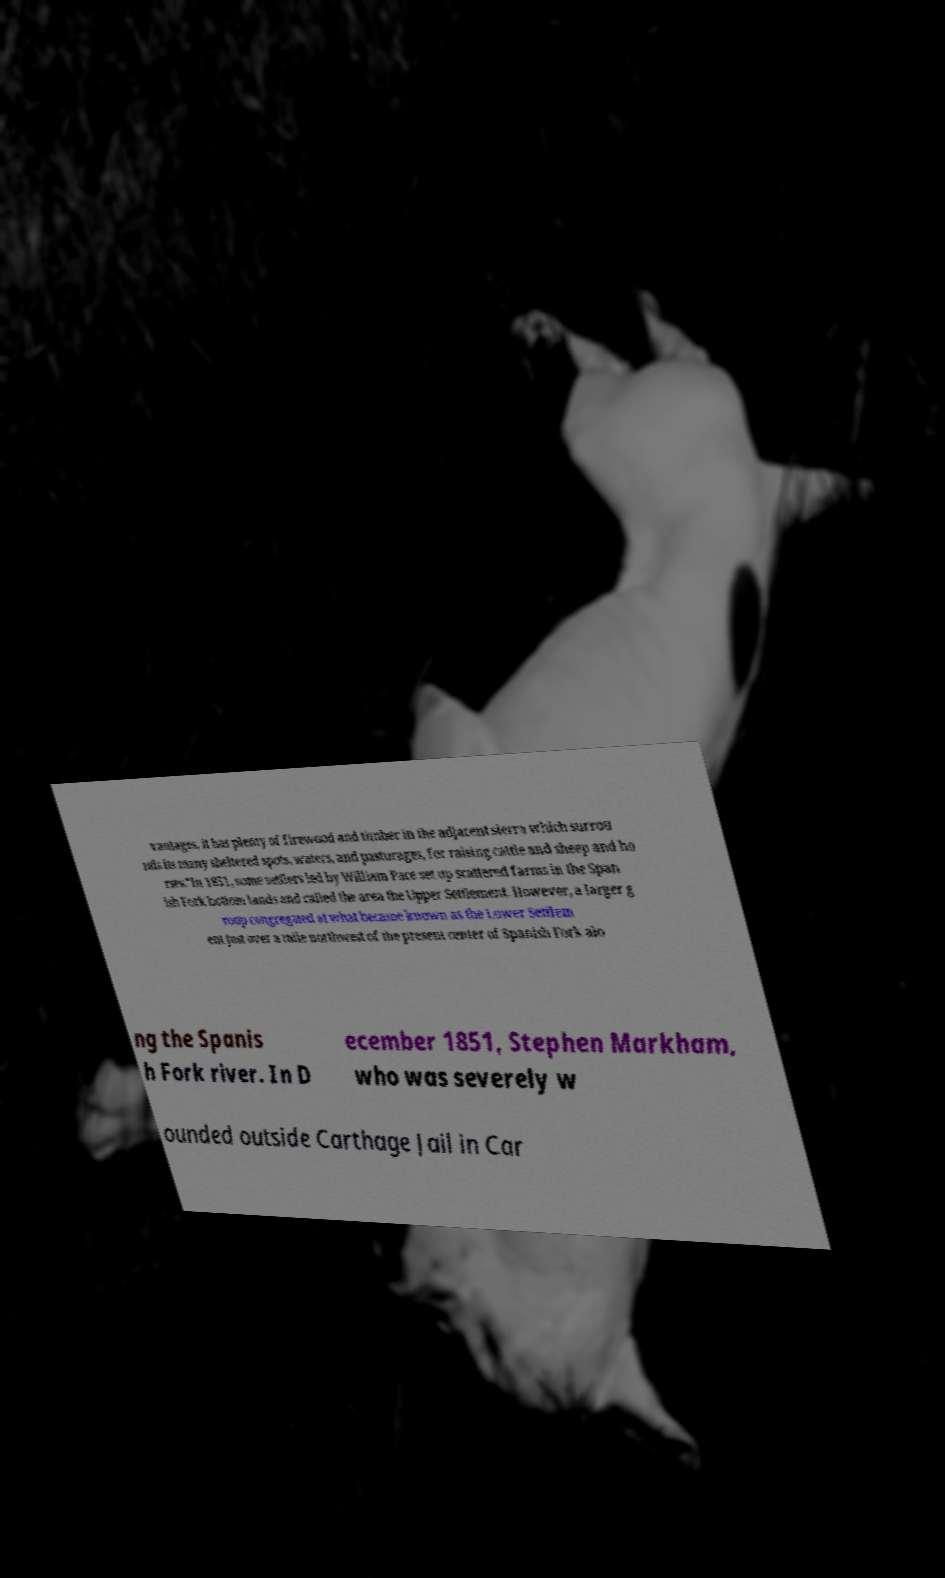Please read and relay the text visible in this image. What does it say? vantages, it has plenty of firewood and timber in the adjacent sierra which surrou nds its many sheltered spots, waters, and pasturages, for raising cattle and sheep and ho rses."In 1851, some settlers led by William Pace set up scattered farms in the Span ish Fork bottom lands and called the area the Upper Settlement. However, a larger g roup congregated at what became known as the Lower Settlem ent just over a mile northwest of the present center of Spanish Fork alo ng the Spanis h Fork river. In D ecember 1851, Stephen Markham, who was severely w ounded outside Carthage Jail in Car 